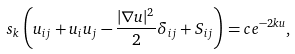<formula> <loc_0><loc_0><loc_500><loc_500>\ s _ { k } \left ( u _ { i j } + u _ { i } u _ { j } - \frac { | \nabla u | ^ { 2 } } { 2 } \delta _ { i j } + S _ { i j } \right ) = c e ^ { - 2 k u } ,</formula> 